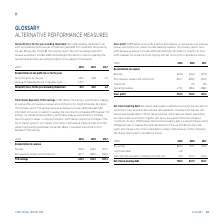According to Torm's financial document, How is TCE earnings defined? TORM defines TCE earnings, a performance measure, as revenue after port expenses, bunkers and commissions incl. freight and bunker derivatives. The document states: "Time Charter Equivalent (TCE) earnings: TORM defines TCE earnings, a performance measure, as revenue after port expenses, bunkers and commissions incl..." Also, How is TCE earnings used as a standard shipping industry performance measure? TCE earnings is a standard shipping industry performance measure used primarily to compare period-to-period changes in a shipping company’s performance irrespective of changes in the mix of charter types (i.e. spot charters, time charters and bareboat charters) under which the vessels may be employed between the periods. The document states: "venue, the most directly comparable IFRS measure. TCE earnings is a standard shipping industry performance measure used primarily to compare period-to..." Also, What are the components under Reconciliation to revenue when calculating TCE earnings? The document shows two values: Revenue and Port expenses, bunkers and commissions. From the document: "Port expenses, bunkers and commissions -267.7 -283.0 -259.9 earnings, a performance measure, as revenue after port expenses, bunkers and commissions i..." Additionally, In which year was Revenue the largest? According to the financial document, 2019. The relevant text states: "USDm 2019 2018 2017..." Also, can you calculate: What was the change in TCE earnings in 2019 from 2018? Based on the calculation: 424.9-352.4, the result is 72.5 (in millions). This is based on the information: "TCE earnings 424.9 352.4 397.1 TCE earnings 424.9 352.4 397.1..." The key data points involved are: 352.4, 424.9. Also, can you calculate: What was the percentage change in TCE earnings in 2019 from 2018? To answer this question, I need to perform calculations using the financial data. The calculation is: (424.9-352.4)/352.4, which equals 20.57 (percentage). This is based on the information: "TCE earnings 424.9 352.4 397.1 TCE earnings 424.9 352.4 397.1..." The key data points involved are: 352.4, 424.9. 